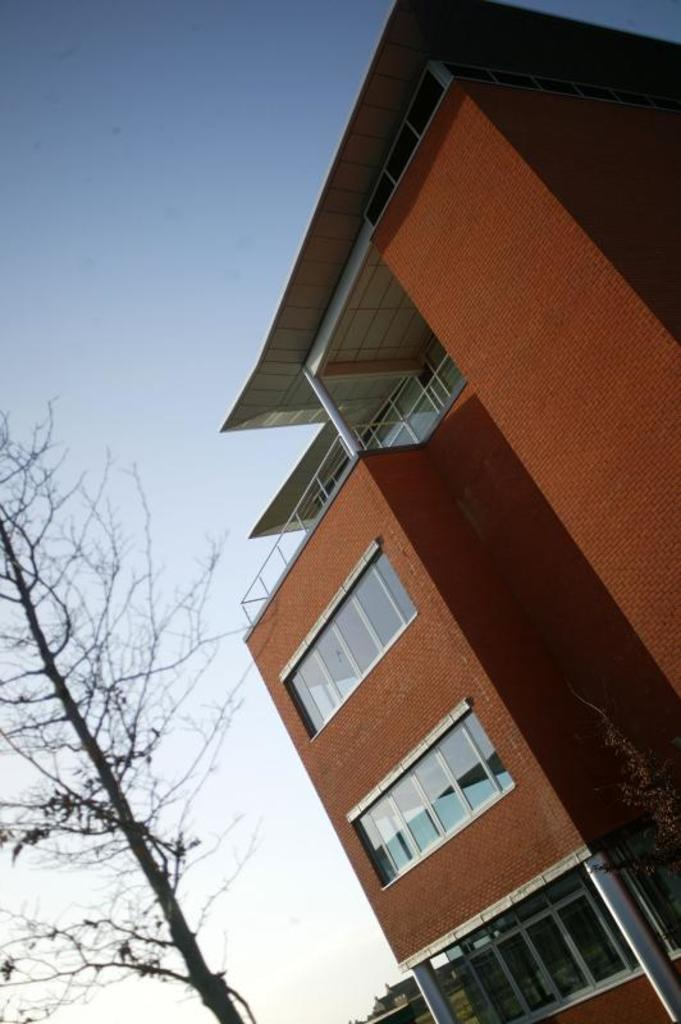What type of structure is in the image? There is a building in the image. What are some features of the building? The building has walls, glass windows, and poles. What can be seen on the left side of the image? There is a tree without leaves on the left side of the image. What is visible in the background of the image? The sky is visible in the background of the image. Where is the pail located in the image? There is no pail present in the image. What type of bead can be seen hanging from the tree without leaves? There are no beads present in the image, and the tree does not have any hanging objects. 